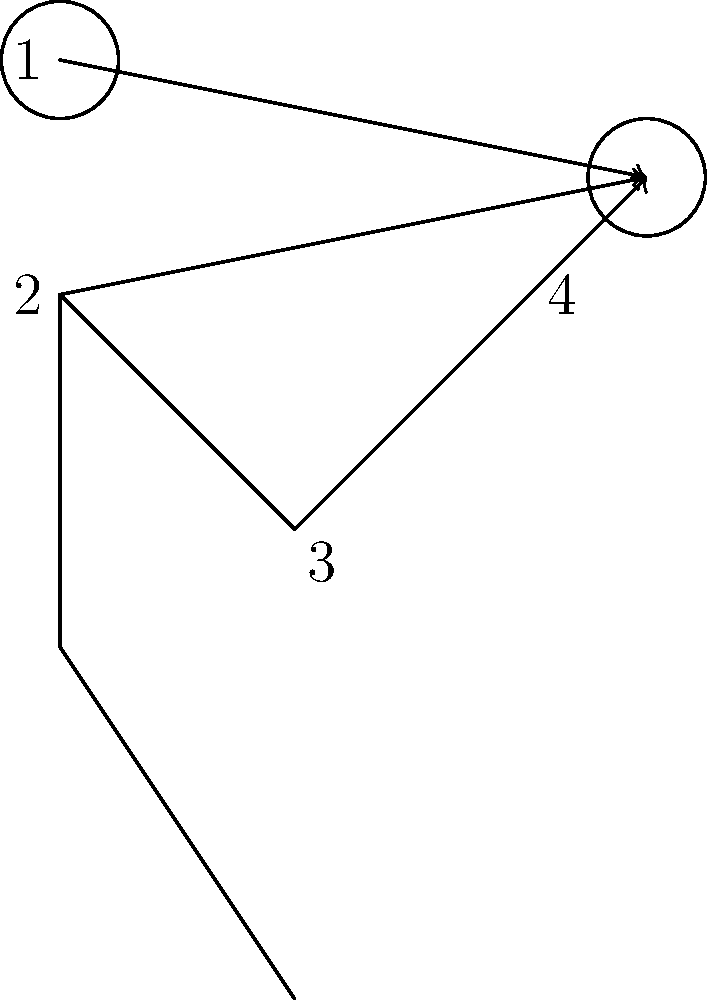In a basketball free throw, the kinetic chain plays a crucial role in generating power and accuracy. Based on the stick figure diagram, which sequence correctly represents the order of joint movements in the kinetic chain for an effective free throw? To understand the kinetic chain in a basketball free throw, we need to analyze the sequence of joint movements from the ground up:

1. The movement starts from the legs, but this is not shown in detail in our diagram.
2. The hip and core provide stability and initiate the upward motion.
3. The shoulder (labeled 2) rotates and extends, transferring energy up the chain.
4. The elbow (labeled 3) extends, further transferring the energy.
5. Finally, the wrist (labeled 4) flexes, providing the final release and spin on the ball.

The head (labeled 1) doesn't actively contribute to the kinetic chain but is important for aiming.

The kinetic chain works by transferring energy from larger, more powerful joints to smaller, more precise joints. This transfer allows for maximum power generation while maintaining control and accuracy.

In the diagram, the arrows indicate the transfer of energy from each joint to the ball. The sequence of this transfer follows the kinetic chain principle, moving from the core of the body outward to the extremities.

Therefore, the correct sequence of joint movements in the kinetic chain for an effective free throw, based on the labeled parts in the diagram, is: 2 (shoulder) → 3 (elbow) → 4 (wrist).
Answer: 2 → 3 → 4 